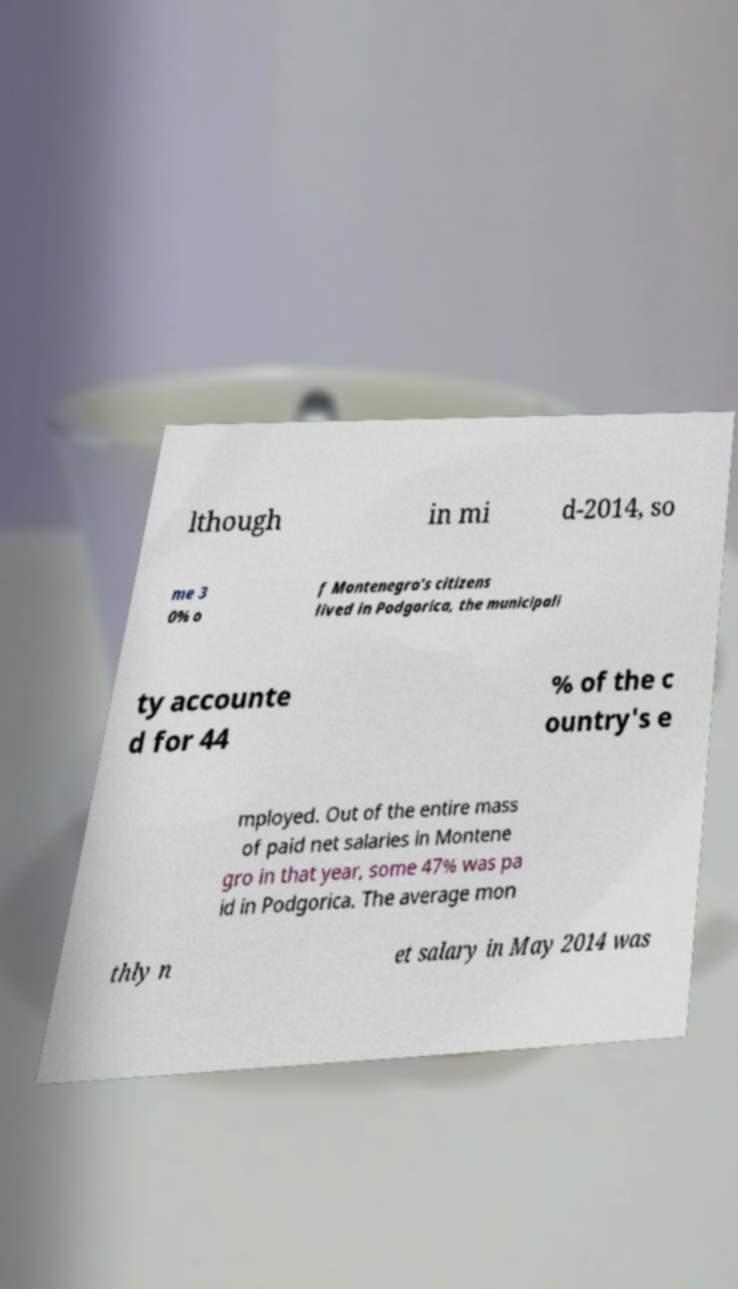For documentation purposes, I need the text within this image transcribed. Could you provide that? lthough in mi d-2014, so me 3 0% o f Montenegro's citizens lived in Podgorica, the municipali ty accounte d for 44 % of the c ountry's e mployed. Out of the entire mass of paid net salaries in Montene gro in that year, some 47% was pa id in Podgorica. The average mon thly n et salary in May 2014 was 